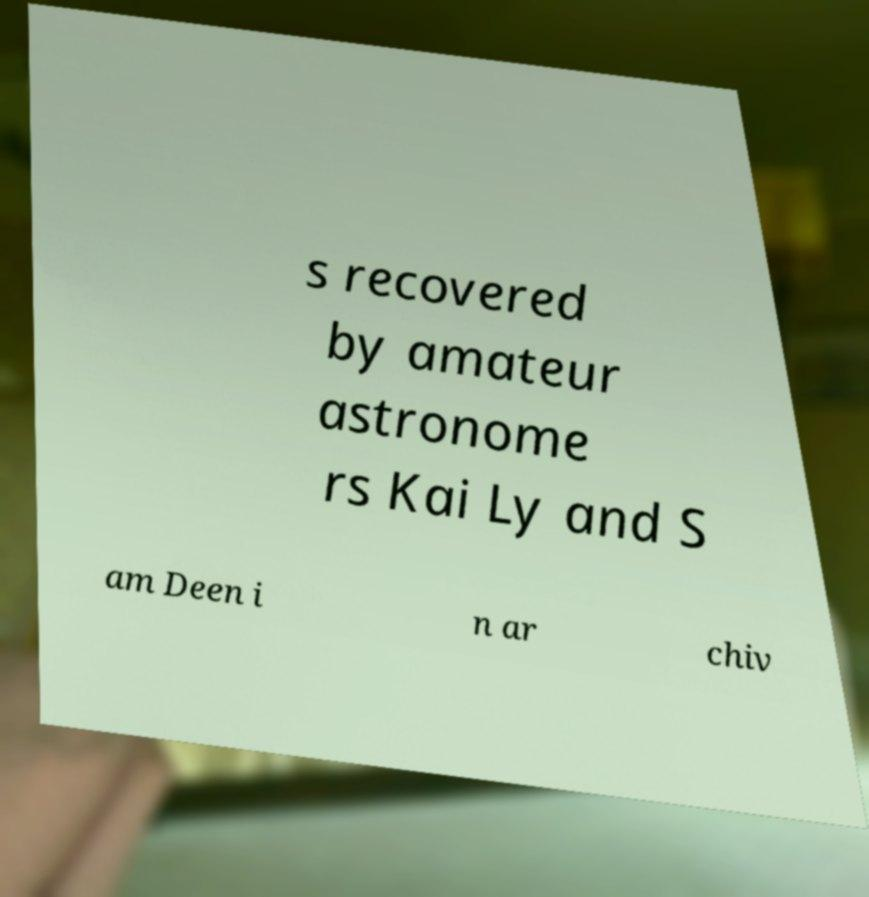For documentation purposes, I need the text within this image transcribed. Could you provide that? s recovered by amateur astronome rs Kai Ly and S am Deen i n ar chiv 